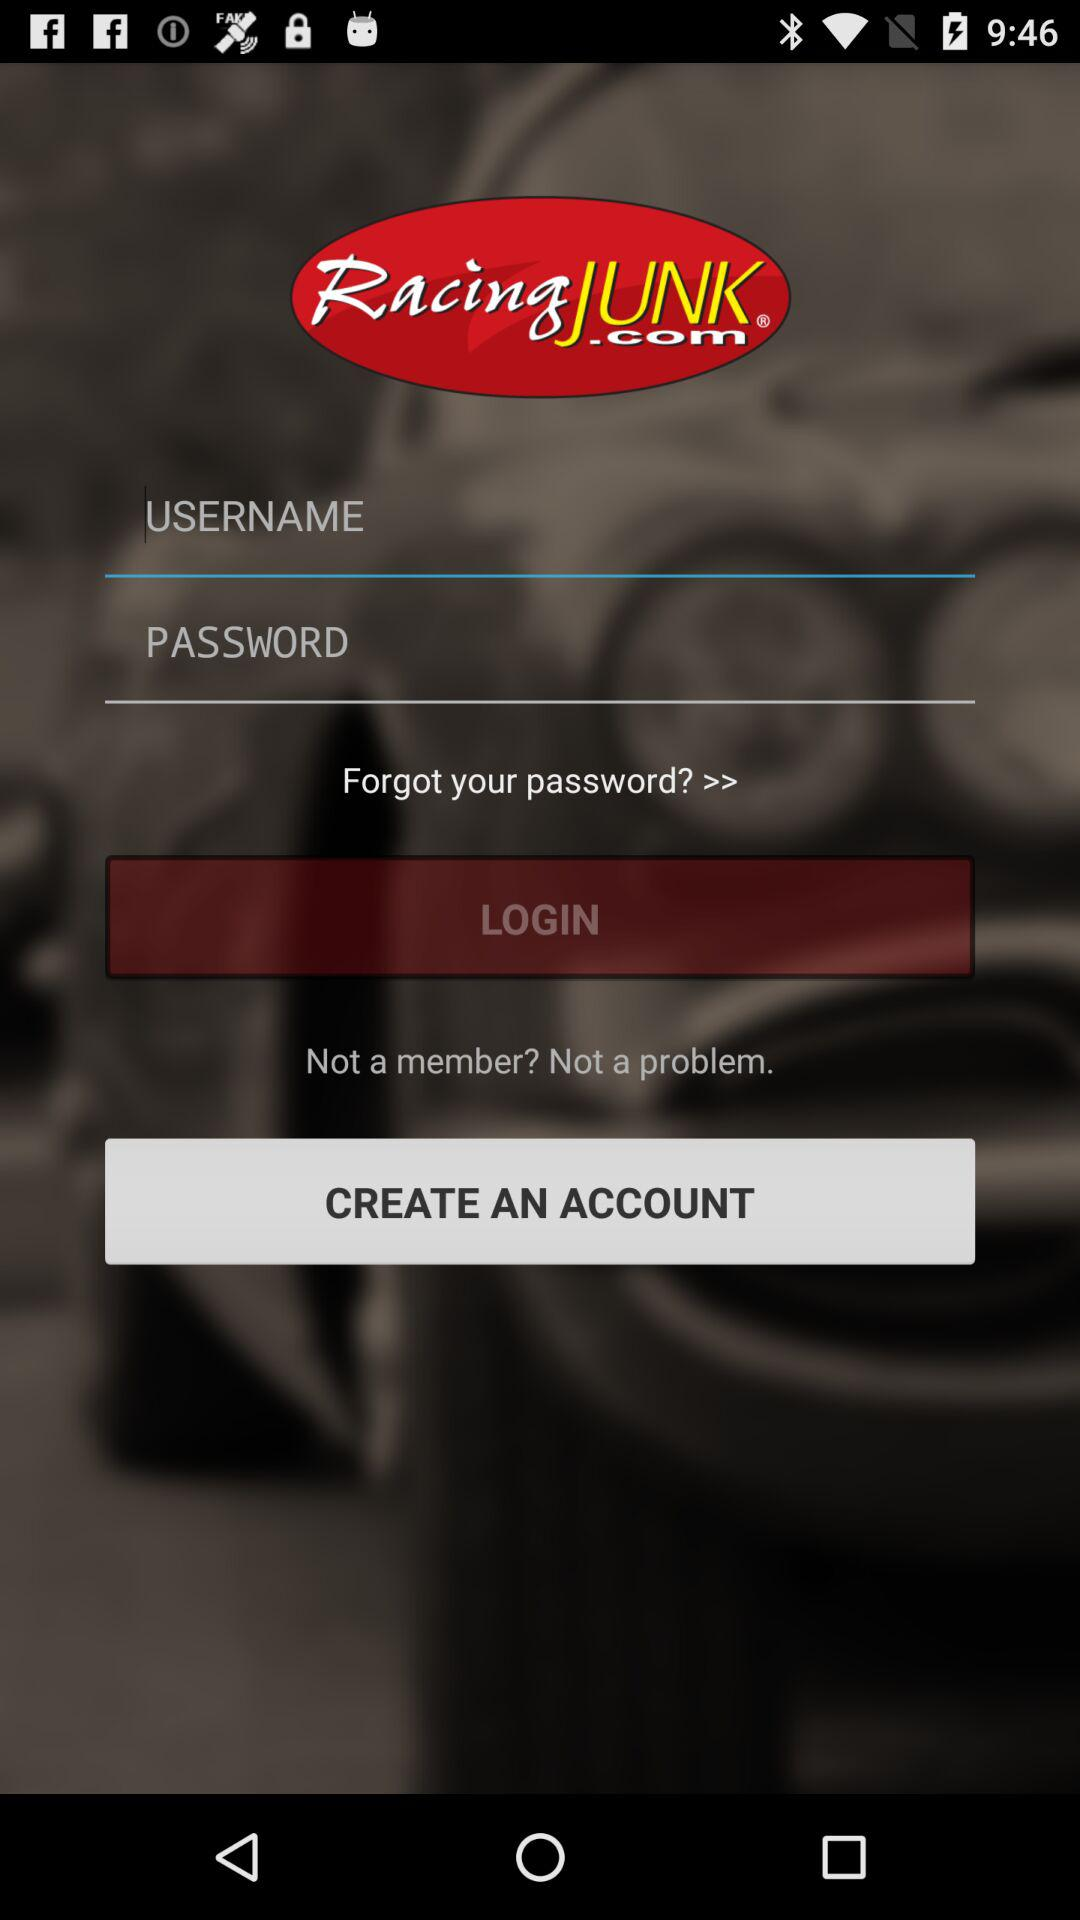What is the name of the application? The name of the application is "RacingJUNK". 